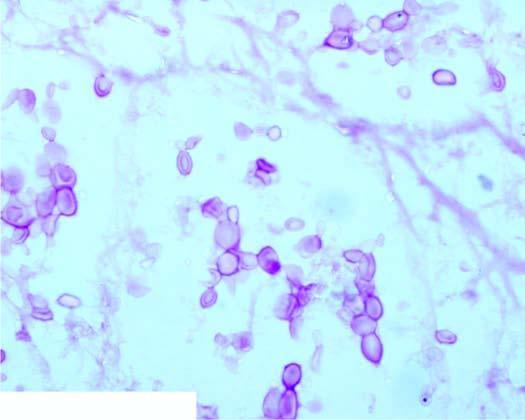s ryptococci in csf as seen in mucicarmine stain?
Answer the question using a single word or phrase. Yes 